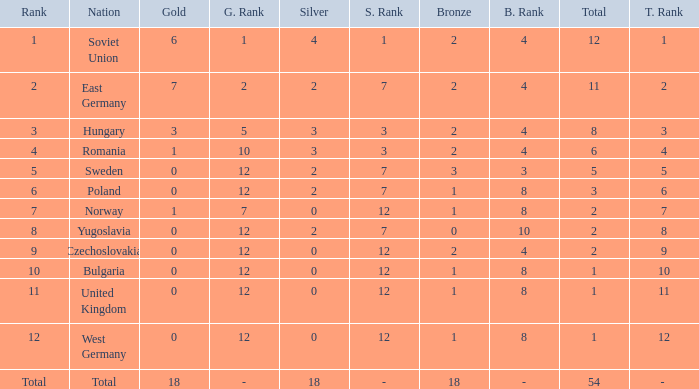What's the highest total of Romania when the bronze was less than 2? None. 